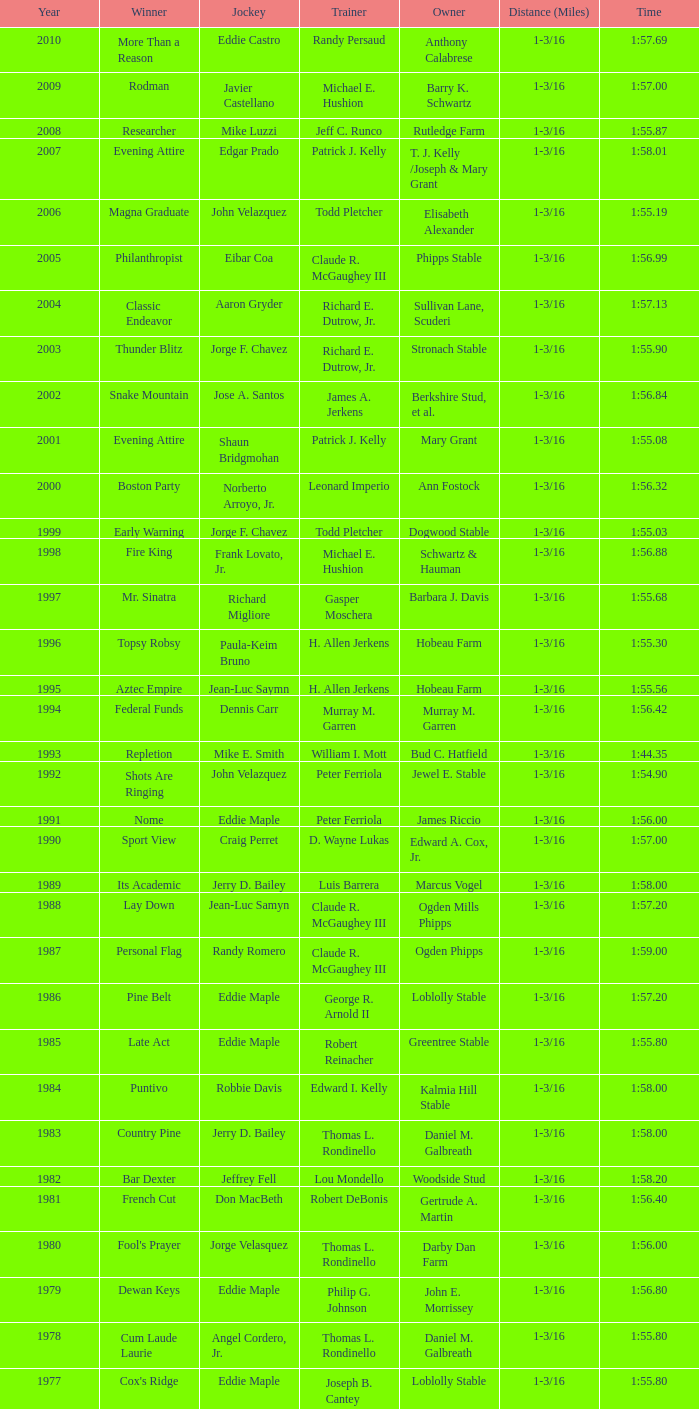What steed triumphed under a trainer with "no race" experience? No Race, No Race, No Race, No Race. 